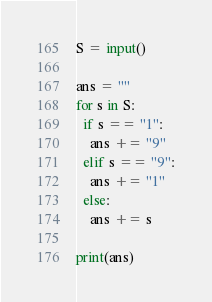Convert code to text. <code><loc_0><loc_0><loc_500><loc_500><_Python_>S = input()

ans = ""
for s in S:
  if s == "1":
    ans += "9"
  elif s == "9":
    ans += "1"
  else:
    ans += s
    
print(ans)    </code> 